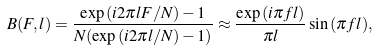Convert formula to latex. <formula><loc_0><loc_0><loc_500><loc_500>B ( F , l ) = \frac { \exp { ( i 2 \pi l F / N ) } - 1 } { N ( \exp { ( i 2 \pi l / N ) } - 1 ) } \approx \frac { \exp { ( i \pi f l ) } } { \pi l } \sin { ( \pi f l ) } ,</formula> 